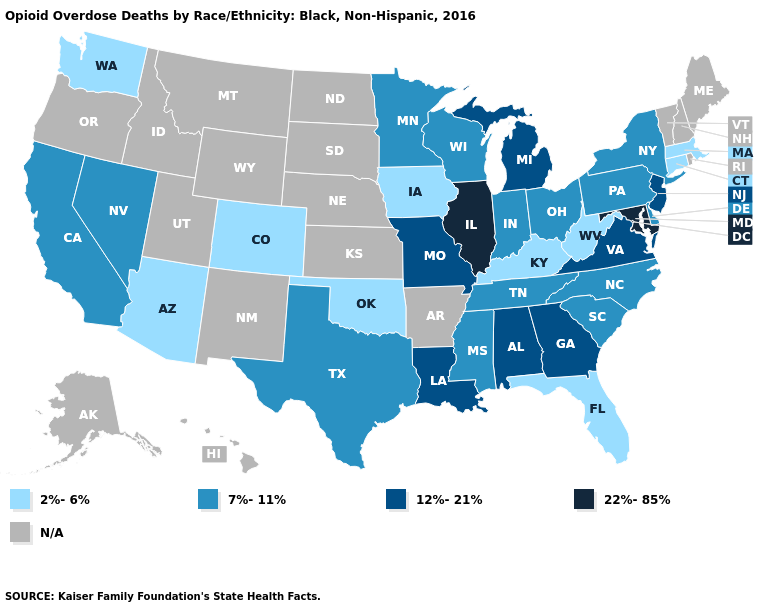Among the states that border West Virginia , does Maryland have the highest value?
Concise answer only. Yes. Name the states that have a value in the range N/A?
Write a very short answer. Alaska, Arkansas, Hawaii, Idaho, Kansas, Maine, Montana, Nebraska, New Hampshire, New Mexico, North Dakota, Oregon, Rhode Island, South Dakota, Utah, Vermont, Wyoming. What is the lowest value in the USA?
Keep it brief. 2%-6%. Name the states that have a value in the range 22%-85%?
Give a very brief answer. Illinois, Maryland. Does Illinois have the highest value in the MidWest?
Short answer required. Yes. Which states have the lowest value in the USA?
Concise answer only. Arizona, Colorado, Connecticut, Florida, Iowa, Kentucky, Massachusetts, Oklahoma, Washington, West Virginia. Which states have the lowest value in the West?
Keep it brief. Arizona, Colorado, Washington. What is the value of Mississippi?
Write a very short answer. 7%-11%. What is the lowest value in the MidWest?
Give a very brief answer. 2%-6%. Does the map have missing data?
Keep it brief. Yes. What is the lowest value in states that border Indiana?
Answer briefly. 2%-6%. Which states have the highest value in the USA?
Be succinct. Illinois, Maryland. Does Nevada have the lowest value in the USA?
Be succinct. No. What is the value of Massachusetts?
Give a very brief answer. 2%-6%. What is the value of Florida?
Be succinct. 2%-6%. 